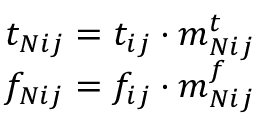Convert formula to latex. <formula><loc_0><loc_0><loc_500><loc_500>\begin{array} { r } { t _ { N i j } = t _ { i j } \cdot m _ { N i j } ^ { t } } \\ { f _ { N i j } = f _ { i j } \cdot m _ { N i j } ^ { f } } \end{array}</formula> 